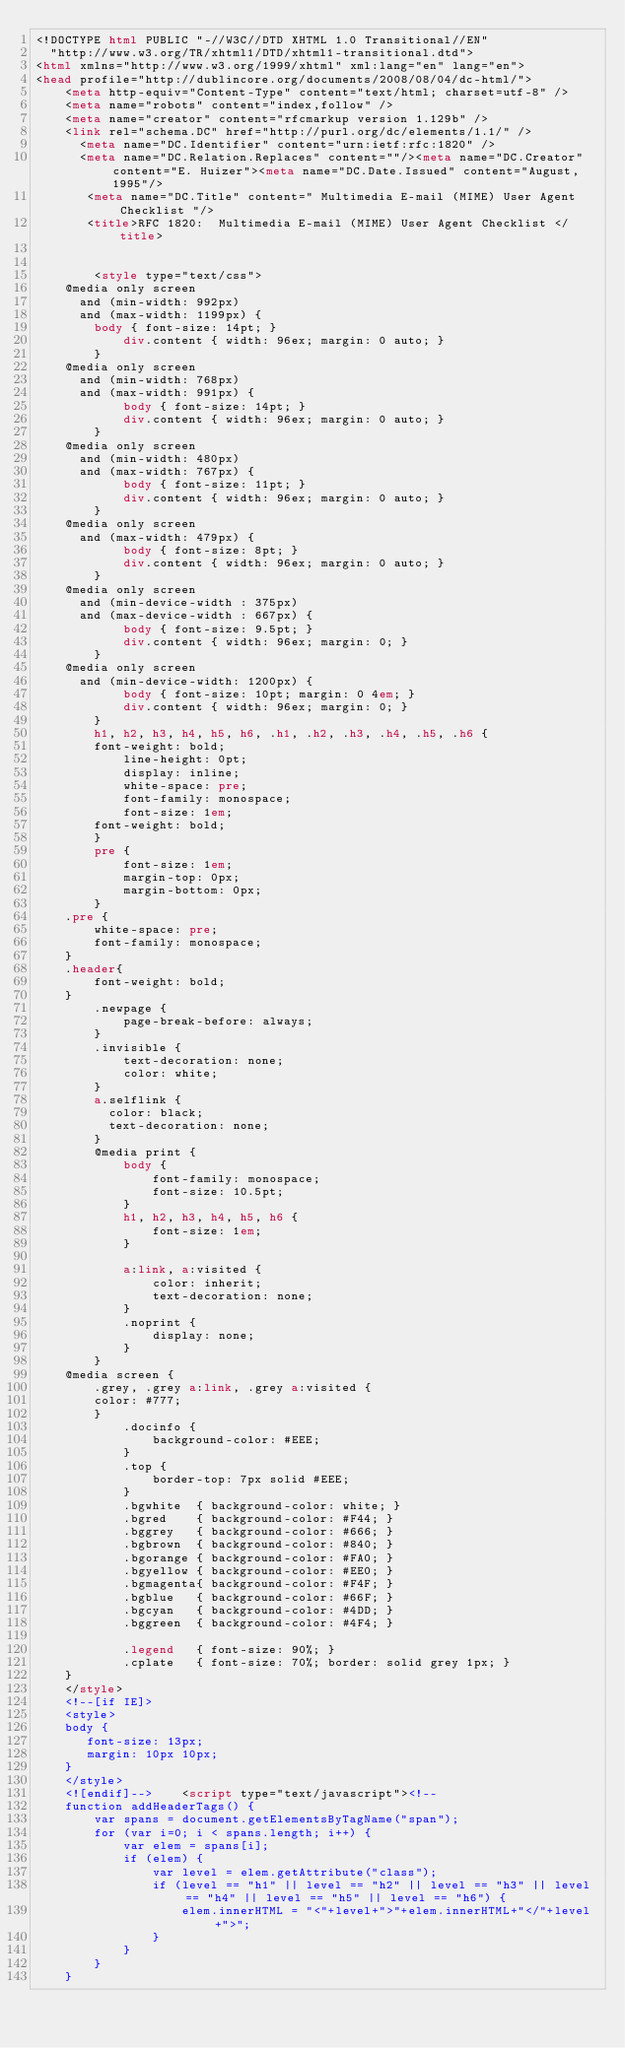Convert code to text. <code><loc_0><loc_0><loc_500><loc_500><_HTML_><!DOCTYPE html PUBLIC "-//W3C//DTD XHTML 1.0 Transitional//EN"
  "http://www.w3.org/TR/xhtml1/DTD/xhtml1-transitional.dtd">
<html xmlns="http://www.w3.org/1999/xhtml" xml:lang="en" lang="en">
<head profile="http://dublincore.org/documents/2008/08/04/dc-html/">
    <meta http-equiv="Content-Type" content="text/html; charset=utf-8" />
    <meta name="robots" content="index,follow" />
    <meta name="creator" content="rfcmarkup version 1.129b" />
    <link rel="schema.DC" href="http://purl.org/dc/elements/1.1/" />
      <meta name="DC.Identifier" content="urn:ietf:rfc:1820" />
      <meta name="DC.Relation.Replaces" content=""/><meta name="DC.Creator" content="E. Huizer"><meta name="DC.Date.Issued" content="August, 1995"/>
       <meta name="DC.Title" content=" Multimedia E-mail (MIME) User Agent Checklist "/>
       <title>RFC 1820:  Multimedia E-mail (MIME) User Agent Checklist </title>    
        

        <style type="text/css">
	@media only screen 
	  and (min-width: 992px)
	  and (max-width: 1199px) {
	    body { font-size: 14pt; }
            div.content { width: 96ex; margin: 0 auto; }
        }
	@media only screen 
	  and (min-width: 768px)
	  and (max-width: 991px) {
            body { font-size: 14pt; }
            div.content { width: 96ex; margin: 0 auto; }
        }
	@media only screen 
	  and (min-width: 480px)
	  and (max-width: 767px) {
            body { font-size: 11pt; }
            div.content { width: 96ex; margin: 0 auto; }
        }
	@media only screen 
	  and (max-width: 479px) {
            body { font-size: 8pt; }
            div.content { width: 96ex; margin: 0 auto; }
        }
	@media only screen 
	  and (min-device-width : 375px) 
	  and (max-device-width : 667px) {
            body { font-size: 9.5pt; }
            div.content { width: 96ex; margin: 0; }
        }
	@media only screen 
	  and (min-device-width: 1200px) {
            body { font-size: 10pt; margin: 0 4em; }
            div.content { width: 96ex; margin: 0; }
        }
        h1, h2, h3, h4, h5, h6, .h1, .h2, .h3, .h4, .h5, .h6 {
	    font-weight: bold;
            line-height: 0pt;
            display: inline;
            white-space: pre;
            font-family: monospace;
            font-size: 1em;
	    font-weight: bold;
        }
        pre {
            font-size: 1em;
            margin-top: 0px;
            margin-bottom: 0px;
        }
	.pre {
	    white-space: pre;
	    font-family: monospace;
	}
	.header{
	    font-weight: bold;
	}
        .newpage {
            page-break-before: always;
        }
        .invisible {
            text-decoration: none;
            color: white;
        }
        a.selflink {
          color: black;
          text-decoration: none;
        }
        @media print {
            body {
                font-family: monospace;
                font-size: 10.5pt;
            }
            h1, h2, h3, h4, h5, h6 {
                font-size: 1em;
            }
        
            a:link, a:visited {
                color: inherit;
                text-decoration: none;
            }
            .noprint {
                display: none;
            }
        }
	@media screen {
	    .grey, .grey a:link, .grey a:visited {
		color: #777;
	    }
            .docinfo {
                background-color: #EEE;
            }
            .top {
                border-top: 7px solid #EEE;
            }
            .bgwhite  { background-color: white; }
            .bgred    { background-color: #F44; }
            .bggrey   { background-color: #666; }
            .bgbrown  { background-color: #840; }            
            .bgorange { background-color: #FA0; }
            .bgyellow { background-color: #EE0; }
            .bgmagenta{ background-color: #F4F; }
            .bgblue   { background-color: #66F; }
            .bgcyan   { background-color: #4DD; }
            .bggreen  { background-color: #4F4; }

            .legend   { font-size: 90%; }
            .cplate   { font-size: 70%; border: solid grey 1px; }
	}
    </style>
    <!--[if IE]>
    <style>
    body {
       font-size: 13px;
       margin: 10px 10px;
    }
    </style>
    <![endif]-->    <script type="text/javascript"><!--
    function addHeaderTags() {
        var spans = document.getElementsByTagName("span");
        for (var i=0; i < spans.length; i++) {
            var elem = spans[i];
            if (elem) {
                var level = elem.getAttribute("class");
                if (level == "h1" || level == "h2" || level == "h3" || level == "h4" || level == "h5" || level == "h6") {
                    elem.innerHTML = "<"+level+">"+elem.innerHTML+"</"+level+">";               
                }
            }
        }
    }</code> 